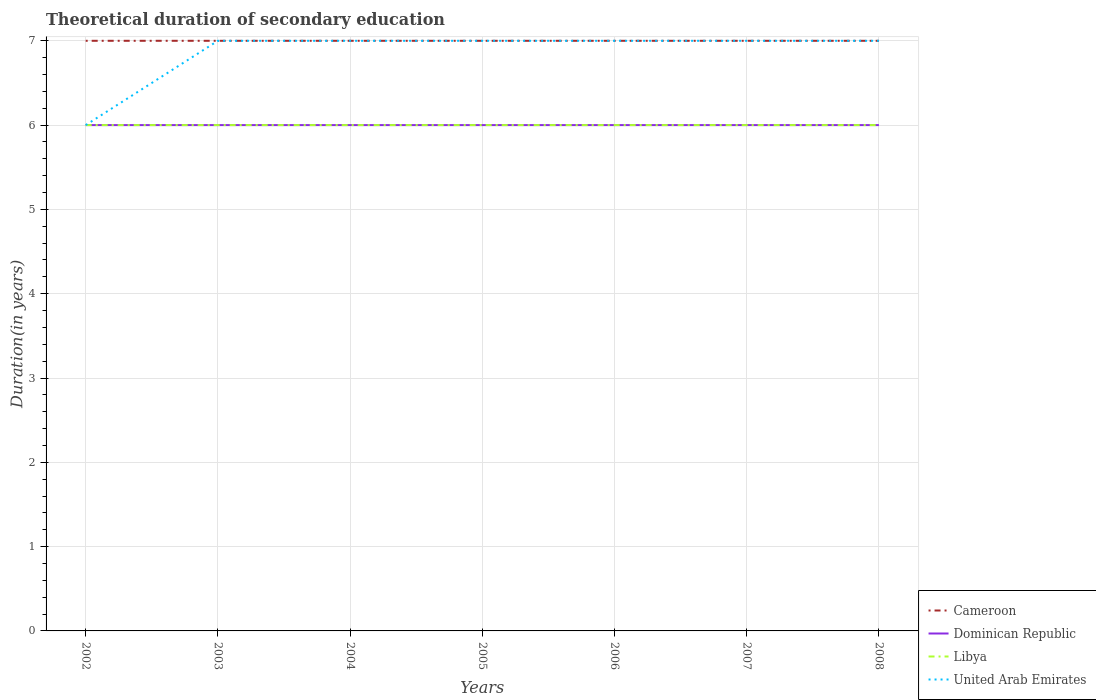How many different coloured lines are there?
Your answer should be very brief. 4. Does the line corresponding to United Arab Emirates intersect with the line corresponding to Libya?
Your response must be concise. Yes. Is the number of lines equal to the number of legend labels?
Provide a succinct answer. Yes. Across all years, what is the maximum total theoretical duration of secondary education in United Arab Emirates?
Your answer should be compact. 6. What is the total total theoretical duration of secondary education in Libya in the graph?
Provide a short and direct response. 0. What is the difference between the highest and the second highest total theoretical duration of secondary education in Cameroon?
Make the answer very short. 0. What is the difference between the highest and the lowest total theoretical duration of secondary education in United Arab Emirates?
Provide a short and direct response. 6. Is the total theoretical duration of secondary education in Dominican Republic strictly greater than the total theoretical duration of secondary education in United Arab Emirates over the years?
Provide a succinct answer. No. What is the difference between two consecutive major ticks on the Y-axis?
Provide a short and direct response. 1. Does the graph contain grids?
Offer a very short reply. Yes. How many legend labels are there?
Keep it short and to the point. 4. What is the title of the graph?
Make the answer very short. Theoretical duration of secondary education. What is the label or title of the X-axis?
Keep it short and to the point. Years. What is the label or title of the Y-axis?
Your answer should be very brief. Duration(in years). What is the Duration(in years) of Dominican Republic in 2003?
Your answer should be very brief. 6. What is the Duration(in years) in United Arab Emirates in 2003?
Provide a short and direct response. 7. What is the Duration(in years) in Dominican Republic in 2005?
Offer a terse response. 6. What is the Duration(in years) in Dominican Republic in 2006?
Keep it short and to the point. 6. What is the Duration(in years) in Cameroon in 2007?
Your response must be concise. 7. What is the Duration(in years) in Dominican Republic in 2007?
Keep it short and to the point. 6. What is the Duration(in years) in Libya in 2007?
Your response must be concise. 6. Across all years, what is the maximum Duration(in years) of Cameroon?
Your response must be concise. 7. Across all years, what is the maximum Duration(in years) of Dominican Republic?
Your answer should be compact. 6. Across all years, what is the minimum Duration(in years) of Cameroon?
Make the answer very short. 7. Across all years, what is the minimum Duration(in years) of Libya?
Offer a very short reply. 6. Across all years, what is the minimum Duration(in years) in United Arab Emirates?
Provide a short and direct response. 6. What is the total Duration(in years) of Cameroon in the graph?
Your answer should be very brief. 49. What is the total Duration(in years) of Dominican Republic in the graph?
Make the answer very short. 42. What is the difference between the Duration(in years) in Libya in 2002 and that in 2003?
Provide a succinct answer. 0. What is the difference between the Duration(in years) of Cameroon in 2002 and that in 2004?
Give a very brief answer. 0. What is the difference between the Duration(in years) in Dominican Republic in 2002 and that in 2004?
Provide a succinct answer. 0. What is the difference between the Duration(in years) in Libya in 2002 and that in 2004?
Your response must be concise. 0. What is the difference between the Duration(in years) in Dominican Republic in 2002 and that in 2005?
Provide a succinct answer. 0. What is the difference between the Duration(in years) in United Arab Emirates in 2002 and that in 2006?
Offer a very short reply. -1. What is the difference between the Duration(in years) of Cameroon in 2002 and that in 2007?
Your answer should be very brief. 0. What is the difference between the Duration(in years) of Cameroon in 2002 and that in 2008?
Offer a terse response. 0. What is the difference between the Duration(in years) of Dominican Republic in 2002 and that in 2008?
Your answer should be compact. 0. What is the difference between the Duration(in years) in Libya in 2002 and that in 2008?
Offer a very short reply. 0. What is the difference between the Duration(in years) in United Arab Emirates in 2002 and that in 2008?
Offer a terse response. -1. What is the difference between the Duration(in years) in United Arab Emirates in 2003 and that in 2004?
Ensure brevity in your answer.  0. What is the difference between the Duration(in years) in Dominican Republic in 2003 and that in 2005?
Offer a terse response. 0. What is the difference between the Duration(in years) in Libya in 2003 and that in 2005?
Provide a short and direct response. 0. What is the difference between the Duration(in years) of United Arab Emirates in 2003 and that in 2005?
Keep it short and to the point. 0. What is the difference between the Duration(in years) of Dominican Republic in 2003 and that in 2006?
Ensure brevity in your answer.  0. What is the difference between the Duration(in years) in United Arab Emirates in 2003 and that in 2006?
Ensure brevity in your answer.  0. What is the difference between the Duration(in years) in Dominican Republic in 2003 and that in 2007?
Your response must be concise. 0. What is the difference between the Duration(in years) in Libya in 2003 and that in 2007?
Give a very brief answer. 0. What is the difference between the Duration(in years) in United Arab Emirates in 2003 and that in 2007?
Provide a succinct answer. 0. What is the difference between the Duration(in years) in United Arab Emirates in 2003 and that in 2008?
Your answer should be very brief. 0. What is the difference between the Duration(in years) of Dominican Republic in 2004 and that in 2005?
Your answer should be compact. 0. What is the difference between the Duration(in years) of Dominican Republic in 2004 and that in 2006?
Offer a very short reply. 0. What is the difference between the Duration(in years) of Cameroon in 2004 and that in 2007?
Make the answer very short. 0. What is the difference between the Duration(in years) of Cameroon in 2004 and that in 2008?
Offer a terse response. 0. What is the difference between the Duration(in years) in Dominican Republic in 2004 and that in 2008?
Provide a short and direct response. 0. What is the difference between the Duration(in years) in Libya in 2004 and that in 2008?
Keep it short and to the point. 0. What is the difference between the Duration(in years) in United Arab Emirates in 2004 and that in 2008?
Your answer should be very brief. 0. What is the difference between the Duration(in years) in Libya in 2005 and that in 2006?
Your answer should be compact. 0. What is the difference between the Duration(in years) of United Arab Emirates in 2005 and that in 2006?
Keep it short and to the point. 0. What is the difference between the Duration(in years) in Dominican Republic in 2005 and that in 2007?
Your response must be concise. 0. What is the difference between the Duration(in years) of Libya in 2005 and that in 2007?
Offer a very short reply. 0. What is the difference between the Duration(in years) in United Arab Emirates in 2005 and that in 2007?
Offer a very short reply. 0. What is the difference between the Duration(in years) of Cameroon in 2005 and that in 2008?
Your answer should be compact. 0. What is the difference between the Duration(in years) in Libya in 2005 and that in 2008?
Make the answer very short. 0. What is the difference between the Duration(in years) of Dominican Republic in 2006 and that in 2007?
Your response must be concise. 0. What is the difference between the Duration(in years) of Dominican Republic in 2006 and that in 2008?
Keep it short and to the point. 0. What is the difference between the Duration(in years) in Libya in 2006 and that in 2008?
Offer a very short reply. 0. What is the difference between the Duration(in years) of United Arab Emirates in 2006 and that in 2008?
Provide a succinct answer. 0. What is the difference between the Duration(in years) in Dominican Republic in 2007 and that in 2008?
Your response must be concise. 0. What is the difference between the Duration(in years) in Libya in 2007 and that in 2008?
Offer a terse response. 0. What is the difference between the Duration(in years) in United Arab Emirates in 2007 and that in 2008?
Offer a terse response. 0. What is the difference between the Duration(in years) in Cameroon in 2002 and the Duration(in years) in Dominican Republic in 2003?
Keep it short and to the point. 1. What is the difference between the Duration(in years) of Cameroon in 2002 and the Duration(in years) of Libya in 2003?
Your answer should be very brief. 1. What is the difference between the Duration(in years) of Cameroon in 2002 and the Duration(in years) of United Arab Emirates in 2003?
Your answer should be compact. 0. What is the difference between the Duration(in years) of Dominican Republic in 2002 and the Duration(in years) of United Arab Emirates in 2003?
Provide a short and direct response. -1. What is the difference between the Duration(in years) in Cameroon in 2002 and the Duration(in years) in Libya in 2004?
Give a very brief answer. 1. What is the difference between the Duration(in years) of Libya in 2002 and the Duration(in years) of United Arab Emirates in 2004?
Your answer should be very brief. -1. What is the difference between the Duration(in years) of Cameroon in 2002 and the Duration(in years) of Dominican Republic in 2005?
Provide a short and direct response. 1. What is the difference between the Duration(in years) in Cameroon in 2002 and the Duration(in years) in Libya in 2005?
Make the answer very short. 1. What is the difference between the Duration(in years) in Dominican Republic in 2002 and the Duration(in years) in Libya in 2005?
Your answer should be very brief. 0. What is the difference between the Duration(in years) of Libya in 2002 and the Duration(in years) of United Arab Emirates in 2005?
Your response must be concise. -1. What is the difference between the Duration(in years) of Dominican Republic in 2002 and the Duration(in years) of Libya in 2006?
Your answer should be very brief. 0. What is the difference between the Duration(in years) in Dominican Republic in 2002 and the Duration(in years) in United Arab Emirates in 2006?
Ensure brevity in your answer.  -1. What is the difference between the Duration(in years) of Cameroon in 2002 and the Duration(in years) of Dominican Republic in 2007?
Make the answer very short. 1. What is the difference between the Duration(in years) in Cameroon in 2002 and the Duration(in years) in Libya in 2007?
Offer a terse response. 1. What is the difference between the Duration(in years) in Cameroon in 2002 and the Duration(in years) in Dominican Republic in 2008?
Keep it short and to the point. 1. What is the difference between the Duration(in years) in Cameroon in 2002 and the Duration(in years) in United Arab Emirates in 2008?
Keep it short and to the point. 0. What is the difference between the Duration(in years) of Cameroon in 2003 and the Duration(in years) of Libya in 2004?
Your answer should be compact. 1. What is the difference between the Duration(in years) in Dominican Republic in 2003 and the Duration(in years) in Libya in 2004?
Your answer should be compact. 0. What is the difference between the Duration(in years) in Cameroon in 2003 and the Duration(in years) in Libya in 2005?
Your response must be concise. 1. What is the difference between the Duration(in years) in Dominican Republic in 2003 and the Duration(in years) in United Arab Emirates in 2005?
Provide a succinct answer. -1. What is the difference between the Duration(in years) in Cameroon in 2003 and the Duration(in years) in Dominican Republic in 2006?
Give a very brief answer. 1. What is the difference between the Duration(in years) in Cameroon in 2003 and the Duration(in years) in Libya in 2006?
Make the answer very short. 1. What is the difference between the Duration(in years) of Cameroon in 2003 and the Duration(in years) of United Arab Emirates in 2006?
Your response must be concise. 0. What is the difference between the Duration(in years) in Libya in 2003 and the Duration(in years) in United Arab Emirates in 2006?
Your answer should be very brief. -1. What is the difference between the Duration(in years) in Cameroon in 2003 and the Duration(in years) in Dominican Republic in 2007?
Your response must be concise. 1. What is the difference between the Duration(in years) in Cameroon in 2003 and the Duration(in years) in United Arab Emirates in 2007?
Your answer should be compact. 0. What is the difference between the Duration(in years) of Dominican Republic in 2003 and the Duration(in years) of United Arab Emirates in 2007?
Give a very brief answer. -1. What is the difference between the Duration(in years) in Libya in 2003 and the Duration(in years) in United Arab Emirates in 2007?
Offer a terse response. -1. What is the difference between the Duration(in years) in Cameroon in 2003 and the Duration(in years) in Libya in 2008?
Ensure brevity in your answer.  1. What is the difference between the Duration(in years) of Cameroon in 2003 and the Duration(in years) of United Arab Emirates in 2008?
Make the answer very short. 0. What is the difference between the Duration(in years) in Dominican Republic in 2003 and the Duration(in years) in Libya in 2008?
Your answer should be compact. 0. What is the difference between the Duration(in years) of Dominican Republic in 2003 and the Duration(in years) of United Arab Emirates in 2008?
Offer a terse response. -1. What is the difference between the Duration(in years) of Cameroon in 2004 and the Duration(in years) of Libya in 2005?
Your response must be concise. 1. What is the difference between the Duration(in years) of Dominican Republic in 2004 and the Duration(in years) of United Arab Emirates in 2005?
Make the answer very short. -1. What is the difference between the Duration(in years) of Cameroon in 2004 and the Duration(in years) of Dominican Republic in 2006?
Provide a succinct answer. 1. What is the difference between the Duration(in years) in Dominican Republic in 2004 and the Duration(in years) in Libya in 2006?
Your response must be concise. 0. What is the difference between the Duration(in years) in Cameroon in 2004 and the Duration(in years) in Dominican Republic in 2007?
Provide a short and direct response. 1. What is the difference between the Duration(in years) in Cameroon in 2004 and the Duration(in years) in Libya in 2007?
Offer a terse response. 1. What is the difference between the Duration(in years) of Dominican Republic in 2004 and the Duration(in years) of Libya in 2007?
Make the answer very short. 0. What is the difference between the Duration(in years) of Dominican Republic in 2004 and the Duration(in years) of United Arab Emirates in 2007?
Give a very brief answer. -1. What is the difference between the Duration(in years) in Libya in 2004 and the Duration(in years) in United Arab Emirates in 2007?
Provide a short and direct response. -1. What is the difference between the Duration(in years) in Cameroon in 2004 and the Duration(in years) in Dominican Republic in 2008?
Provide a succinct answer. 1. What is the difference between the Duration(in years) in Cameroon in 2004 and the Duration(in years) in Libya in 2008?
Your response must be concise. 1. What is the difference between the Duration(in years) of Libya in 2004 and the Duration(in years) of United Arab Emirates in 2008?
Offer a very short reply. -1. What is the difference between the Duration(in years) of Cameroon in 2005 and the Duration(in years) of Dominican Republic in 2006?
Offer a very short reply. 1. What is the difference between the Duration(in years) of Cameroon in 2005 and the Duration(in years) of Libya in 2006?
Give a very brief answer. 1. What is the difference between the Duration(in years) of Libya in 2005 and the Duration(in years) of United Arab Emirates in 2006?
Ensure brevity in your answer.  -1. What is the difference between the Duration(in years) in Dominican Republic in 2005 and the Duration(in years) in Libya in 2007?
Your answer should be compact. 0. What is the difference between the Duration(in years) of Dominican Republic in 2005 and the Duration(in years) of United Arab Emirates in 2007?
Offer a very short reply. -1. What is the difference between the Duration(in years) in Cameroon in 2005 and the Duration(in years) in Dominican Republic in 2008?
Keep it short and to the point. 1. What is the difference between the Duration(in years) of Dominican Republic in 2005 and the Duration(in years) of United Arab Emirates in 2008?
Ensure brevity in your answer.  -1. What is the difference between the Duration(in years) in Libya in 2005 and the Duration(in years) in United Arab Emirates in 2008?
Make the answer very short. -1. What is the difference between the Duration(in years) of Cameroon in 2006 and the Duration(in years) of Dominican Republic in 2007?
Your response must be concise. 1. What is the difference between the Duration(in years) of Cameroon in 2006 and the Duration(in years) of Libya in 2007?
Provide a short and direct response. 1. What is the difference between the Duration(in years) of Cameroon in 2006 and the Duration(in years) of United Arab Emirates in 2007?
Offer a very short reply. 0. What is the difference between the Duration(in years) of Cameroon in 2006 and the Duration(in years) of Dominican Republic in 2008?
Offer a very short reply. 1. What is the difference between the Duration(in years) in Cameroon in 2006 and the Duration(in years) in Libya in 2008?
Give a very brief answer. 1. What is the difference between the Duration(in years) of Dominican Republic in 2006 and the Duration(in years) of Libya in 2008?
Keep it short and to the point. 0. What is the difference between the Duration(in years) of Cameroon in 2007 and the Duration(in years) of Libya in 2008?
Offer a terse response. 1. What is the difference between the Duration(in years) of Dominican Republic in 2007 and the Duration(in years) of United Arab Emirates in 2008?
Your answer should be compact. -1. What is the average Duration(in years) of Dominican Republic per year?
Ensure brevity in your answer.  6. What is the average Duration(in years) in Libya per year?
Offer a terse response. 6. What is the average Duration(in years) of United Arab Emirates per year?
Give a very brief answer. 6.86. In the year 2002, what is the difference between the Duration(in years) of Cameroon and Duration(in years) of United Arab Emirates?
Your answer should be compact. 1. In the year 2002, what is the difference between the Duration(in years) of Dominican Republic and Duration(in years) of United Arab Emirates?
Keep it short and to the point. 0. In the year 2003, what is the difference between the Duration(in years) of Cameroon and Duration(in years) of Dominican Republic?
Give a very brief answer. 1. In the year 2003, what is the difference between the Duration(in years) of Cameroon and Duration(in years) of Libya?
Ensure brevity in your answer.  1. In the year 2003, what is the difference between the Duration(in years) of Cameroon and Duration(in years) of United Arab Emirates?
Give a very brief answer. 0. In the year 2003, what is the difference between the Duration(in years) of Dominican Republic and Duration(in years) of Libya?
Keep it short and to the point. 0. In the year 2003, what is the difference between the Duration(in years) in Dominican Republic and Duration(in years) in United Arab Emirates?
Your answer should be compact. -1. In the year 2004, what is the difference between the Duration(in years) of Cameroon and Duration(in years) of Dominican Republic?
Keep it short and to the point. 1. In the year 2004, what is the difference between the Duration(in years) in Dominican Republic and Duration(in years) in Libya?
Keep it short and to the point. 0. In the year 2005, what is the difference between the Duration(in years) of Cameroon and Duration(in years) of Dominican Republic?
Ensure brevity in your answer.  1. In the year 2005, what is the difference between the Duration(in years) of Cameroon and Duration(in years) of United Arab Emirates?
Offer a terse response. 0. In the year 2006, what is the difference between the Duration(in years) in Cameroon and Duration(in years) in United Arab Emirates?
Keep it short and to the point. 0. In the year 2006, what is the difference between the Duration(in years) in Dominican Republic and Duration(in years) in United Arab Emirates?
Your answer should be compact. -1. In the year 2007, what is the difference between the Duration(in years) of Cameroon and Duration(in years) of Dominican Republic?
Make the answer very short. 1. In the year 2007, what is the difference between the Duration(in years) of Cameroon and Duration(in years) of United Arab Emirates?
Your answer should be very brief. 0. In the year 2007, what is the difference between the Duration(in years) in Dominican Republic and Duration(in years) in United Arab Emirates?
Your response must be concise. -1. In the year 2008, what is the difference between the Duration(in years) in Cameroon and Duration(in years) in Dominican Republic?
Give a very brief answer. 1. In the year 2008, what is the difference between the Duration(in years) in Cameroon and Duration(in years) in United Arab Emirates?
Make the answer very short. 0. In the year 2008, what is the difference between the Duration(in years) of Libya and Duration(in years) of United Arab Emirates?
Your answer should be compact. -1. What is the ratio of the Duration(in years) in Libya in 2002 to that in 2003?
Offer a terse response. 1. What is the ratio of the Duration(in years) of United Arab Emirates in 2002 to that in 2003?
Offer a terse response. 0.86. What is the ratio of the Duration(in years) in Cameroon in 2002 to that in 2004?
Offer a very short reply. 1. What is the ratio of the Duration(in years) in Dominican Republic in 2002 to that in 2004?
Keep it short and to the point. 1. What is the ratio of the Duration(in years) in Libya in 2002 to that in 2004?
Provide a succinct answer. 1. What is the ratio of the Duration(in years) of Cameroon in 2002 to that in 2005?
Make the answer very short. 1. What is the ratio of the Duration(in years) in Dominican Republic in 2002 to that in 2005?
Offer a terse response. 1. What is the ratio of the Duration(in years) in Libya in 2002 to that in 2005?
Your answer should be compact. 1. What is the ratio of the Duration(in years) in United Arab Emirates in 2002 to that in 2005?
Make the answer very short. 0.86. What is the ratio of the Duration(in years) of United Arab Emirates in 2002 to that in 2006?
Provide a short and direct response. 0.86. What is the ratio of the Duration(in years) of Dominican Republic in 2002 to that in 2007?
Your answer should be compact. 1. What is the ratio of the Duration(in years) in Libya in 2002 to that in 2007?
Provide a short and direct response. 1. What is the ratio of the Duration(in years) of United Arab Emirates in 2002 to that in 2007?
Your answer should be very brief. 0.86. What is the ratio of the Duration(in years) of Cameroon in 2002 to that in 2008?
Provide a succinct answer. 1. What is the ratio of the Duration(in years) of United Arab Emirates in 2003 to that in 2004?
Offer a terse response. 1. What is the ratio of the Duration(in years) of Dominican Republic in 2003 to that in 2005?
Make the answer very short. 1. What is the ratio of the Duration(in years) of Libya in 2003 to that in 2007?
Make the answer very short. 1. What is the ratio of the Duration(in years) of Cameroon in 2003 to that in 2008?
Keep it short and to the point. 1. What is the ratio of the Duration(in years) in Libya in 2003 to that in 2008?
Offer a terse response. 1. What is the ratio of the Duration(in years) of United Arab Emirates in 2003 to that in 2008?
Provide a short and direct response. 1. What is the ratio of the Duration(in years) of Cameroon in 2004 to that in 2005?
Your answer should be very brief. 1. What is the ratio of the Duration(in years) in Libya in 2004 to that in 2005?
Ensure brevity in your answer.  1. What is the ratio of the Duration(in years) of United Arab Emirates in 2004 to that in 2005?
Ensure brevity in your answer.  1. What is the ratio of the Duration(in years) in Cameroon in 2004 to that in 2006?
Your response must be concise. 1. What is the ratio of the Duration(in years) of United Arab Emirates in 2004 to that in 2006?
Keep it short and to the point. 1. What is the ratio of the Duration(in years) of Cameroon in 2004 to that in 2007?
Keep it short and to the point. 1. What is the ratio of the Duration(in years) in Dominican Republic in 2004 to that in 2007?
Offer a very short reply. 1. What is the ratio of the Duration(in years) in Libya in 2004 to that in 2007?
Keep it short and to the point. 1. What is the ratio of the Duration(in years) in Dominican Republic in 2004 to that in 2008?
Your answer should be very brief. 1. What is the ratio of the Duration(in years) of Libya in 2005 to that in 2006?
Your response must be concise. 1. What is the ratio of the Duration(in years) of United Arab Emirates in 2005 to that in 2006?
Make the answer very short. 1. What is the ratio of the Duration(in years) of Cameroon in 2005 to that in 2007?
Your answer should be compact. 1. What is the ratio of the Duration(in years) in Libya in 2005 to that in 2008?
Your response must be concise. 1. What is the ratio of the Duration(in years) in Cameroon in 2006 to that in 2007?
Offer a terse response. 1. What is the ratio of the Duration(in years) of Libya in 2006 to that in 2007?
Make the answer very short. 1. What is the ratio of the Duration(in years) in Dominican Republic in 2006 to that in 2008?
Provide a succinct answer. 1. What is the ratio of the Duration(in years) in United Arab Emirates in 2006 to that in 2008?
Your answer should be very brief. 1. What is the ratio of the Duration(in years) in Dominican Republic in 2007 to that in 2008?
Offer a very short reply. 1. What is the ratio of the Duration(in years) in United Arab Emirates in 2007 to that in 2008?
Your answer should be compact. 1. What is the difference between the highest and the second highest Duration(in years) in Dominican Republic?
Your answer should be very brief. 0. What is the difference between the highest and the second highest Duration(in years) in United Arab Emirates?
Ensure brevity in your answer.  0. What is the difference between the highest and the lowest Duration(in years) in United Arab Emirates?
Provide a succinct answer. 1. 